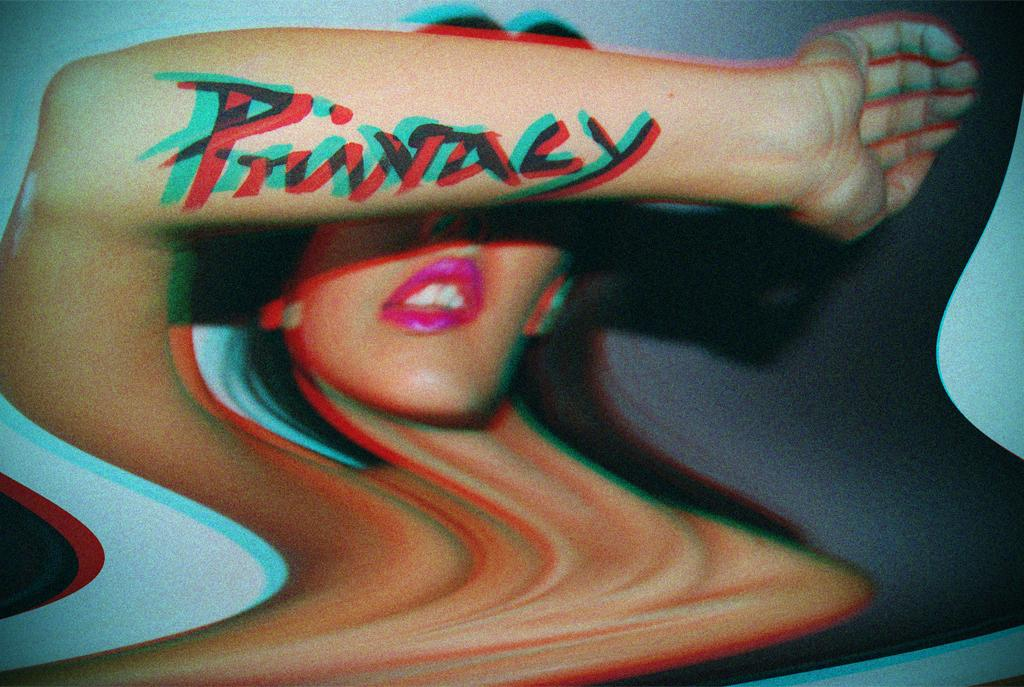What is the main subject of the image? The main subject of the image is an edited picture of a woman. What can be seen on the woman's hand in the image? There is text on the woman's hand in the image. What color is the background of the image? The background of the image is blue. Reasoning: Let'g: Let's think step by step in order to produce the conversation. We start by identifying the main subject of the image, which is the edited picture of a woman. Then, we describe the specific detail of the text on her hand. Finally, we mention the color of the background, which is blue. We ensure that each question can be answered definitively with the information given and avoid yes/no questions. Absurd Question/Answer: How many ants can be seen crawling on the woman's hand in the image? There are no ants present in the image; it features an edited picture of a woman with text on her hand. Can you tell me what type of ticket the woman is holding in the image? There is no ticket visible in the image; it only shows an edited picture of a woman with text on her hand and a blue background. Is the woman taking a bath in the image? There is no indication of a bath or any water-related activity in the image; it features an edited picture of a woman with text on her hand and a blue background. 